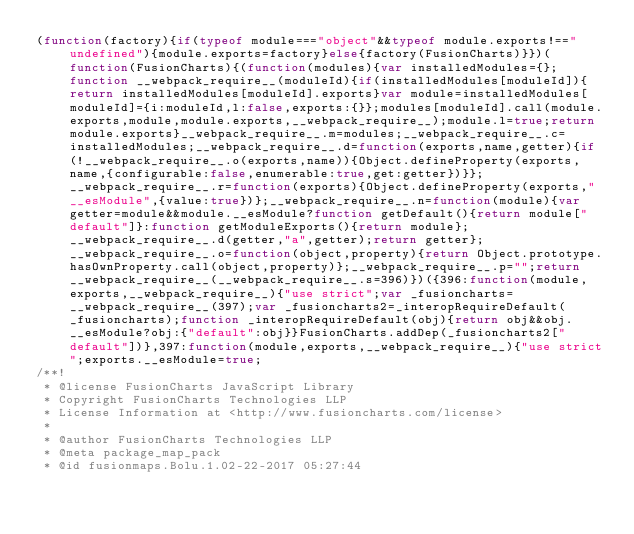<code> <loc_0><loc_0><loc_500><loc_500><_JavaScript_>(function(factory){if(typeof module==="object"&&typeof module.exports!=="undefined"){module.exports=factory}else{factory(FusionCharts)}})(function(FusionCharts){(function(modules){var installedModules={};function __webpack_require__(moduleId){if(installedModules[moduleId]){return installedModules[moduleId].exports}var module=installedModules[moduleId]={i:moduleId,l:false,exports:{}};modules[moduleId].call(module.exports,module,module.exports,__webpack_require__);module.l=true;return module.exports}__webpack_require__.m=modules;__webpack_require__.c=installedModules;__webpack_require__.d=function(exports,name,getter){if(!__webpack_require__.o(exports,name)){Object.defineProperty(exports,name,{configurable:false,enumerable:true,get:getter})}};__webpack_require__.r=function(exports){Object.defineProperty(exports,"__esModule",{value:true})};__webpack_require__.n=function(module){var getter=module&&module.__esModule?function getDefault(){return module["default"]}:function getModuleExports(){return module};__webpack_require__.d(getter,"a",getter);return getter};__webpack_require__.o=function(object,property){return Object.prototype.hasOwnProperty.call(object,property)};__webpack_require__.p="";return __webpack_require__(__webpack_require__.s=396)})({396:function(module,exports,__webpack_require__){"use strict";var _fusioncharts=__webpack_require__(397);var _fusioncharts2=_interopRequireDefault(_fusioncharts);function _interopRequireDefault(obj){return obj&&obj.__esModule?obj:{"default":obj}}FusionCharts.addDep(_fusioncharts2["default"])},397:function(module,exports,__webpack_require__){"use strict";exports.__esModule=true;
/**!
 * @license FusionCharts JavaScript Library
 * Copyright FusionCharts Technologies LLP
 * License Information at <http://www.fusioncharts.com/license>
 *
 * @author FusionCharts Technologies LLP
 * @meta package_map_pack
 * @id fusionmaps.Bolu.1.02-22-2017 05:27:44</code> 